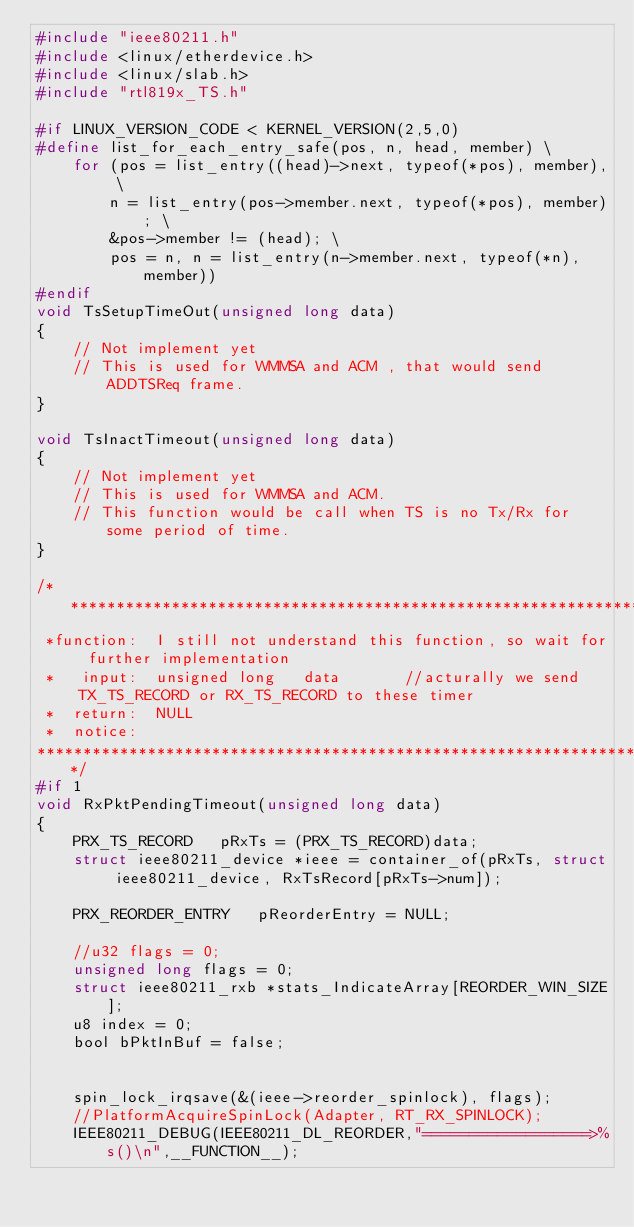<code> <loc_0><loc_0><loc_500><loc_500><_C_>#include "ieee80211.h"
#include <linux/etherdevice.h>
#include <linux/slab.h>
#include "rtl819x_TS.h"

#if LINUX_VERSION_CODE < KERNEL_VERSION(2,5,0)
#define list_for_each_entry_safe(pos, n, head, member) \
	for (pos = list_entry((head)->next, typeof(*pos), member), \
		n = list_entry(pos->member.next, typeof(*pos), member); \
		&pos->member != (head); \
		pos = n, n = list_entry(n->member.next, typeof(*n), member))
#endif
void TsSetupTimeOut(unsigned long data)
{
	// Not implement yet
	// This is used for WMMSA and ACM , that would send ADDTSReq frame.
}

void TsInactTimeout(unsigned long data)
{
	// Not implement yet
	// This is used for WMMSA and ACM.
	// This function would be call when TS is no Tx/Rx for some period of time.
}

/********************************************************************************************************************
 *function:  I still not understand this function, so wait for further implementation
 *   input:  unsigned long	 data		//acturally we send TX_TS_RECORD or RX_TS_RECORD to these timer
 *  return:  NULL
 *  notice:
********************************************************************************************************************/
#if 1
void RxPktPendingTimeout(unsigned long data)
{
	PRX_TS_RECORD	pRxTs = (PRX_TS_RECORD)data;
	struct ieee80211_device *ieee = container_of(pRxTs, struct ieee80211_device, RxTsRecord[pRxTs->num]);

	PRX_REORDER_ENTRY 	pReorderEntry = NULL;

	//u32 flags = 0;
	unsigned long flags = 0;
	struct ieee80211_rxb *stats_IndicateArray[REORDER_WIN_SIZE];
	u8 index = 0;
	bool bPktInBuf = false;


	spin_lock_irqsave(&(ieee->reorder_spinlock), flags);
	//PlatformAcquireSpinLock(Adapter, RT_RX_SPINLOCK);
	IEEE80211_DEBUG(IEEE80211_DL_REORDER,"==================>%s()\n",__FUNCTION__);</code> 